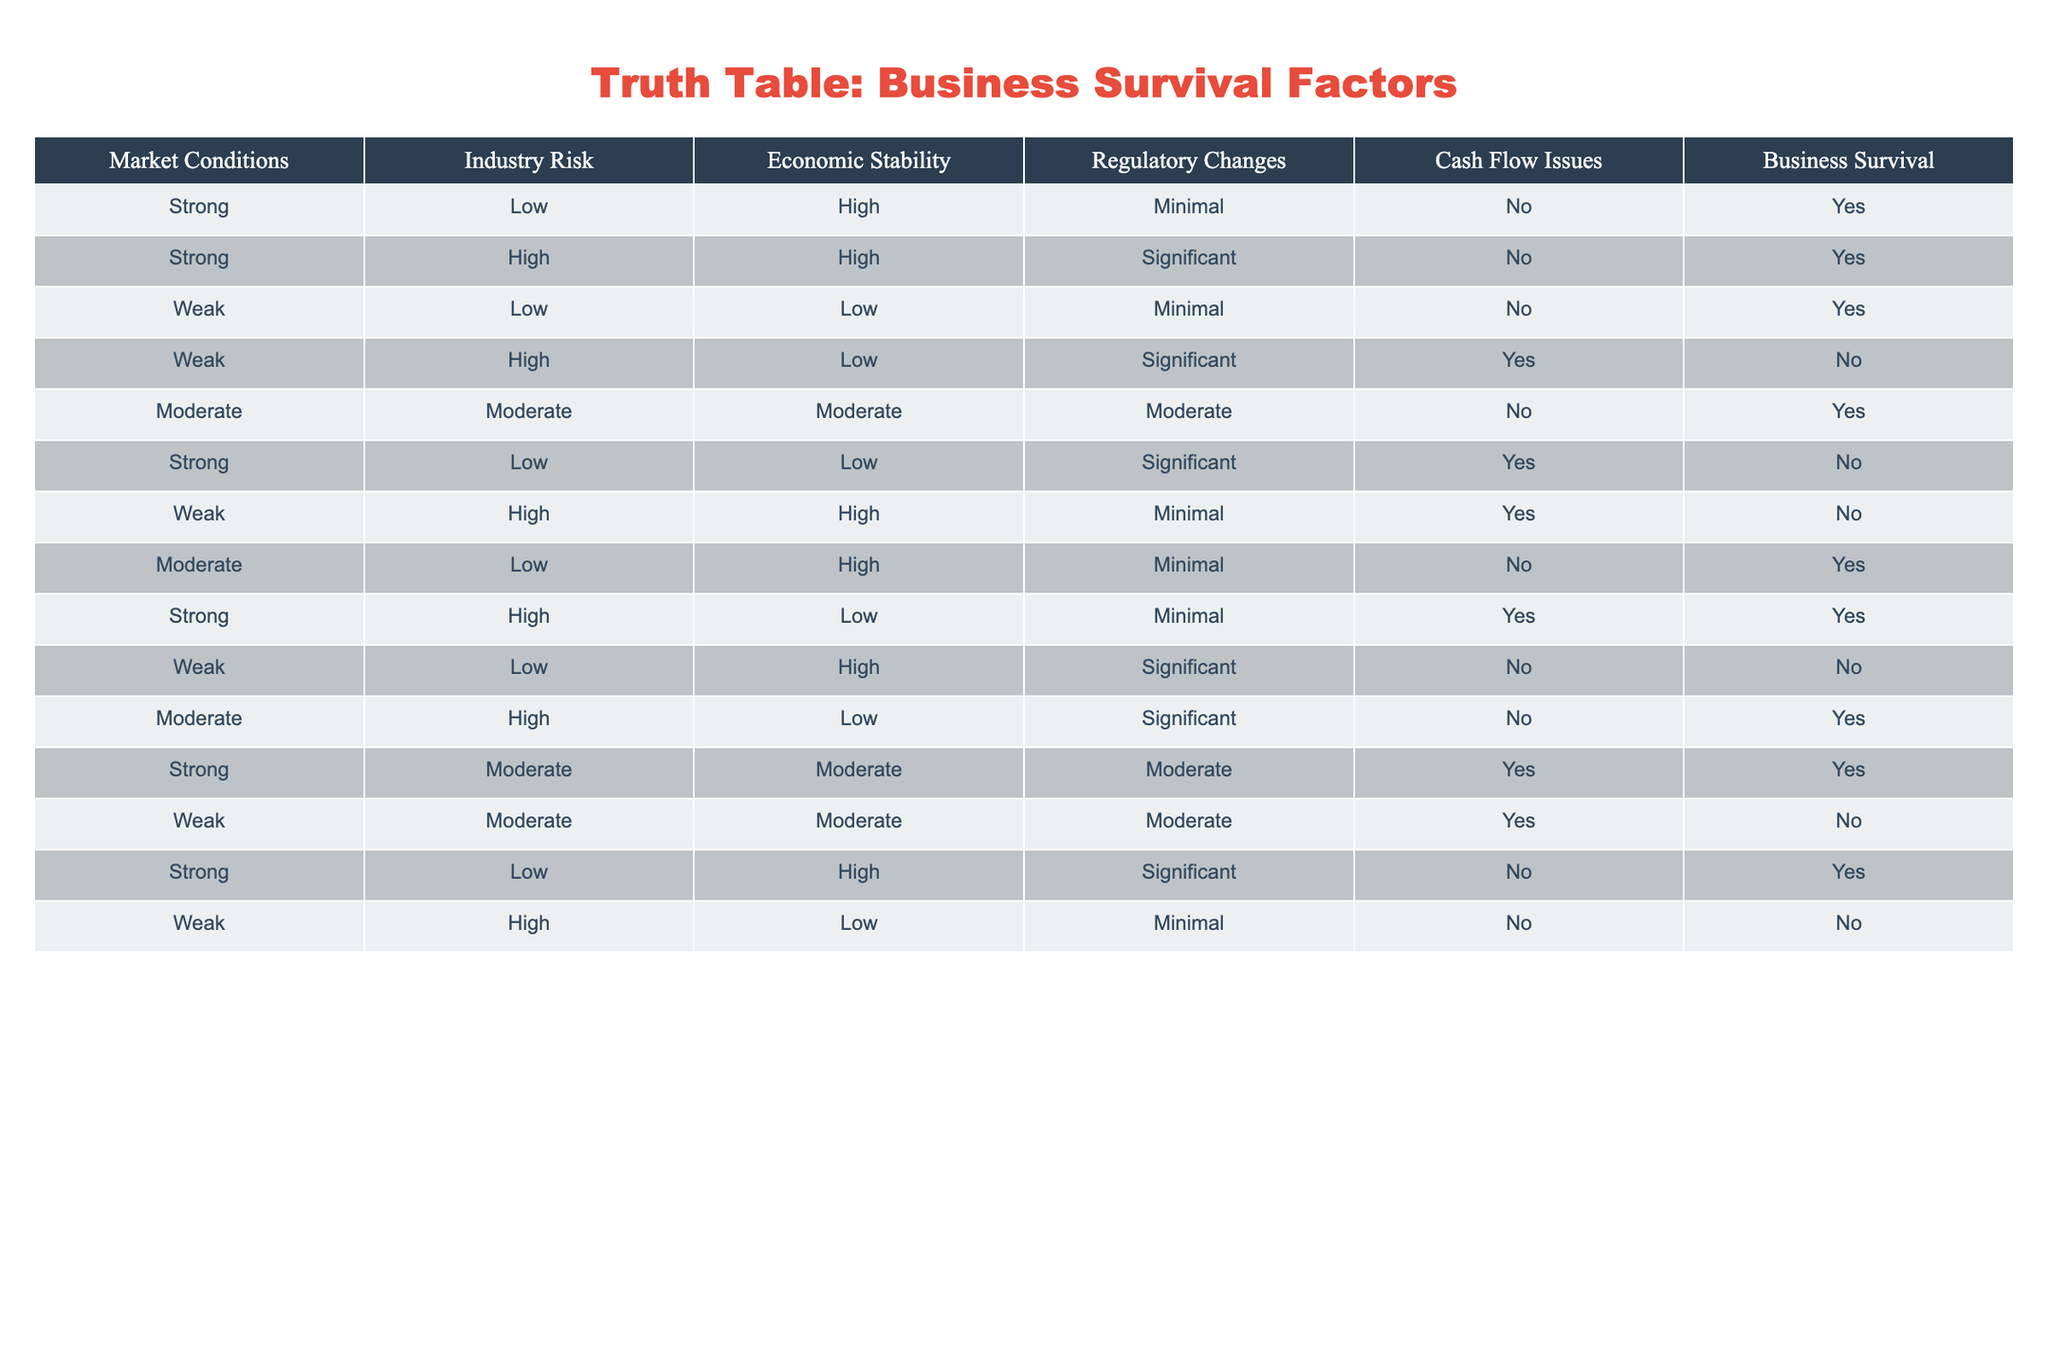What is the business survival rate when market conditions are strong and industry risk is low? There are 4 instances in the table where market conditions are strong and industry risk is low. Out of these, 3 instances have business survival marked as Yes. Therefore, the survival rate is 3 out of 4, which is 75%.
Answer: 75% How many rows report business survival as "No"? To find the total number of "No" responses for business survival, we can count the entries in the "Business Survival" column. There are 5 rows where business survival is marked as No.
Answer: 5 What is the trend in business survival when cash flow issues are present versus when they are absent? There are 7 rows with cash flow issues and 8 rows without. In the presence of cash flow issues, business survival is marked as Yes only twice (2 out of 7), whereas in the absence of cash flow issues, business survival is marked as Yes 6 times (6 out of 8). This indicates a significant trend where business survival is less likely when cash flow issues are present.
Answer: Business survival is less likely when cash flow issues are present Is weak market condition and high industry risk combination always leading to business failure? There are 3 instances of weak market conditions with high industry risk. Out of these, 2 lead to business survival being marked as No, but there is one instance where survival is Yes. Therefore, it is not accurate to say that it always leads to failure.
Answer: No What is the total number of entries for moderate market conditions? There are 3 rows showing moderate market conditions. Each can be found by scanning the "Market Conditions" column and counting the occurrences of "Moderate." Each of these rows will show the associated risk factors and business survival statuses.
Answer: 3 How does regulatory change impact business survival when economic stability is high? There are 3 entries with high economic stability. Out of these, 2 have minimal regulatory change (both survive), and 1 has significant regulatory change (does not survive). This suggests that minimal regulatory change in times of high economic stability is favorable for business survival.
Answer: Favorable for business survival What percentage of businesses survive when both market conditions are weak and industry risks are high? In the case of weak market conditions and high industry risk, there are 3 entries. Out of these entries, only 1 shows business survival as Yes. Thus, the survival percentage is calculated as (1/3)*100 = 33.33%.
Answer: 33.33% Is it true that businesses with strong market conditions and significant regulatory changes never survive? Despite strong market conditions and significant regulatory changes, there are 2 instances. One shows survival as Yes, thus disproving the statement. Therefore, it's false that businesses in these conditions never survive.
Answer: No 